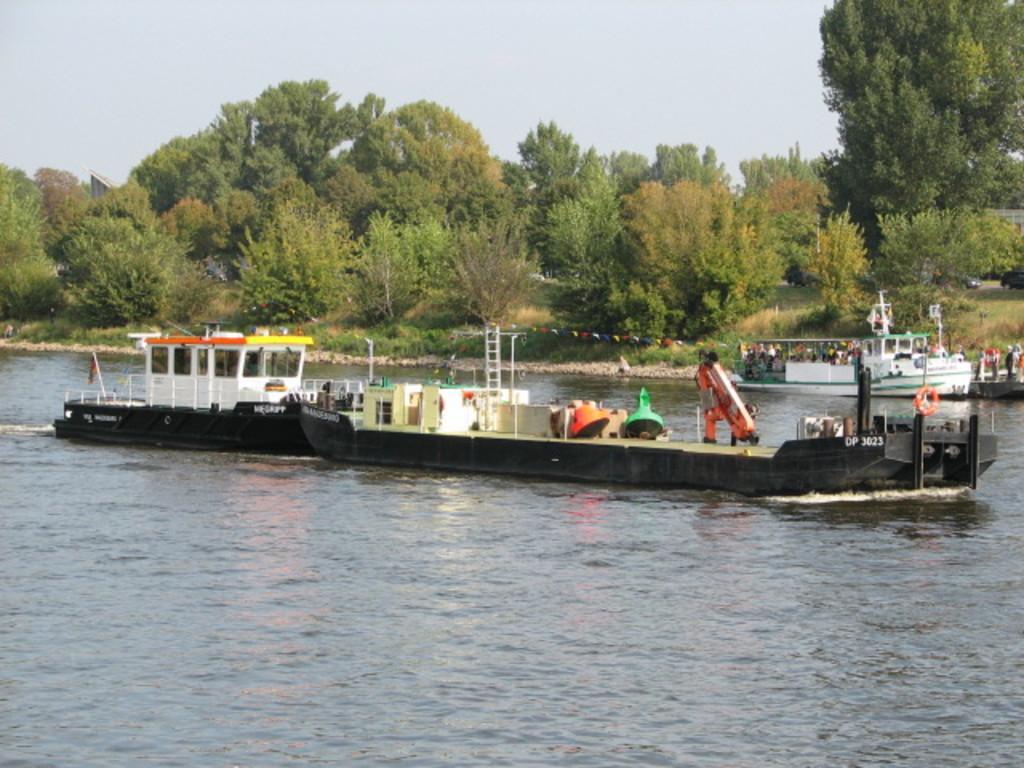In one or two sentences, can you explain what this image depicts? In this picture we can see few boats on the water and we can find few people in the boats, in the background we can see few trees. 